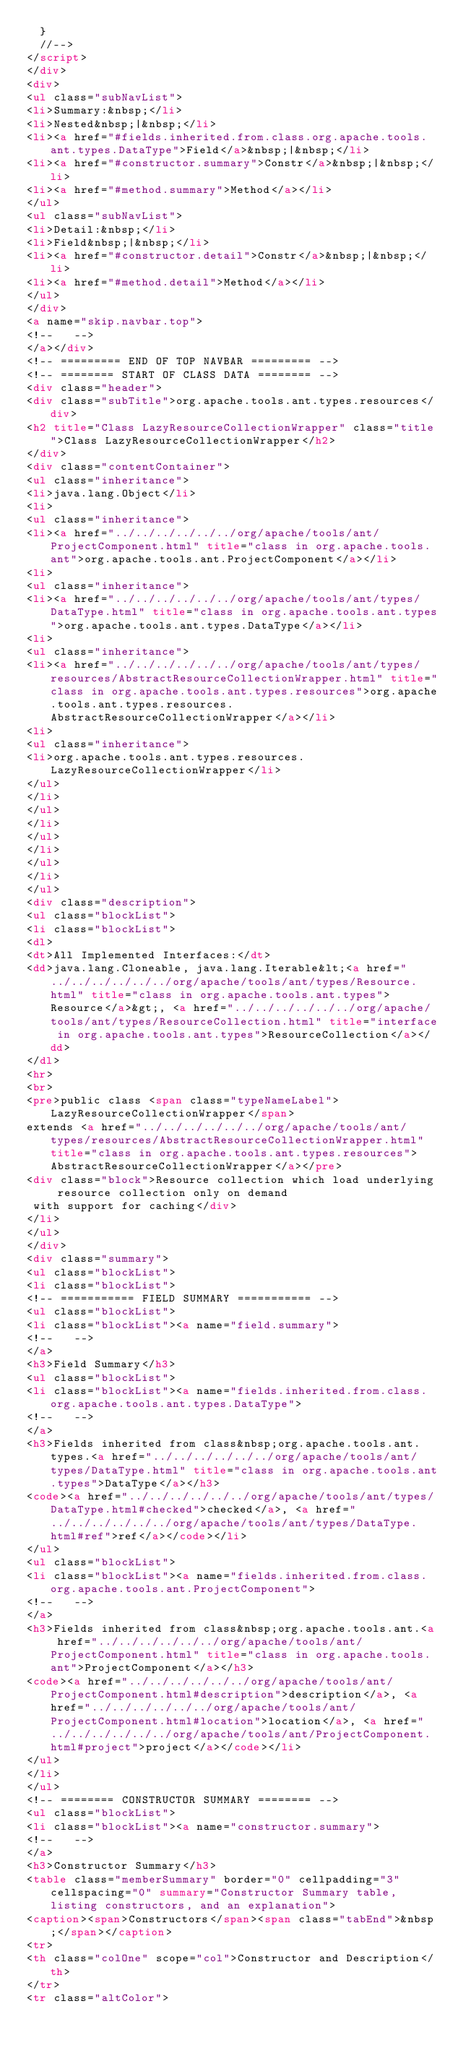Convert code to text. <code><loc_0><loc_0><loc_500><loc_500><_HTML_>  }
  //-->
</script>
</div>
<div>
<ul class="subNavList">
<li>Summary:&nbsp;</li>
<li>Nested&nbsp;|&nbsp;</li>
<li><a href="#fields.inherited.from.class.org.apache.tools.ant.types.DataType">Field</a>&nbsp;|&nbsp;</li>
<li><a href="#constructor.summary">Constr</a>&nbsp;|&nbsp;</li>
<li><a href="#method.summary">Method</a></li>
</ul>
<ul class="subNavList">
<li>Detail:&nbsp;</li>
<li>Field&nbsp;|&nbsp;</li>
<li><a href="#constructor.detail">Constr</a>&nbsp;|&nbsp;</li>
<li><a href="#method.detail">Method</a></li>
</ul>
</div>
<a name="skip.navbar.top">
<!--   -->
</a></div>
<!-- ========= END OF TOP NAVBAR ========= -->
<!-- ======== START OF CLASS DATA ======== -->
<div class="header">
<div class="subTitle">org.apache.tools.ant.types.resources</div>
<h2 title="Class LazyResourceCollectionWrapper" class="title">Class LazyResourceCollectionWrapper</h2>
</div>
<div class="contentContainer">
<ul class="inheritance">
<li>java.lang.Object</li>
<li>
<ul class="inheritance">
<li><a href="../../../../../../org/apache/tools/ant/ProjectComponent.html" title="class in org.apache.tools.ant">org.apache.tools.ant.ProjectComponent</a></li>
<li>
<ul class="inheritance">
<li><a href="../../../../../../org/apache/tools/ant/types/DataType.html" title="class in org.apache.tools.ant.types">org.apache.tools.ant.types.DataType</a></li>
<li>
<ul class="inheritance">
<li><a href="../../../../../../org/apache/tools/ant/types/resources/AbstractResourceCollectionWrapper.html" title="class in org.apache.tools.ant.types.resources">org.apache.tools.ant.types.resources.AbstractResourceCollectionWrapper</a></li>
<li>
<ul class="inheritance">
<li>org.apache.tools.ant.types.resources.LazyResourceCollectionWrapper</li>
</ul>
</li>
</ul>
</li>
</ul>
</li>
</ul>
</li>
</ul>
<div class="description">
<ul class="blockList">
<li class="blockList">
<dl>
<dt>All Implemented Interfaces:</dt>
<dd>java.lang.Cloneable, java.lang.Iterable&lt;<a href="../../../../../../org/apache/tools/ant/types/Resource.html" title="class in org.apache.tools.ant.types">Resource</a>&gt;, <a href="../../../../../../org/apache/tools/ant/types/ResourceCollection.html" title="interface in org.apache.tools.ant.types">ResourceCollection</a></dd>
</dl>
<hr>
<br>
<pre>public class <span class="typeNameLabel">LazyResourceCollectionWrapper</span>
extends <a href="../../../../../../org/apache/tools/ant/types/resources/AbstractResourceCollectionWrapper.html" title="class in org.apache.tools.ant.types.resources">AbstractResourceCollectionWrapper</a></pre>
<div class="block">Resource collection which load underlying resource collection only on demand
 with support for caching</div>
</li>
</ul>
</div>
<div class="summary">
<ul class="blockList">
<li class="blockList">
<!-- =========== FIELD SUMMARY =========== -->
<ul class="blockList">
<li class="blockList"><a name="field.summary">
<!--   -->
</a>
<h3>Field Summary</h3>
<ul class="blockList">
<li class="blockList"><a name="fields.inherited.from.class.org.apache.tools.ant.types.DataType">
<!--   -->
</a>
<h3>Fields inherited from class&nbsp;org.apache.tools.ant.types.<a href="../../../../../../org/apache/tools/ant/types/DataType.html" title="class in org.apache.tools.ant.types">DataType</a></h3>
<code><a href="../../../../../../org/apache/tools/ant/types/DataType.html#checked">checked</a>, <a href="../../../../../../org/apache/tools/ant/types/DataType.html#ref">ref</a></code></li>
</ul>
<ul class="blockList">
<li class="blockList"><a name="fields.inherited.from.class.org.apache.tools.ant.ProjectComponent">
<!--   -->
</a>
<h3>Fields inherited from class&nbsp;org.apache.tools.ant.<a href="../../../../../../org/apache/tools/ant/ProjectComponent.html" title="class in org.apache.tools.ant">ProjectComponent</a></h3>
<code><a href="../../../../../../org/apache/tools/ant/ProjectComponent.html#description">description</a>, <a href="../../../../../../org/apache/tools/ant/ProjectComponent.html#location">location</a>, <a href="../../../../../../org/apache/tools/ant/ProjectComponent.html#project">project</a></code></li>
</ul>
</li>
</ul>
<!-- ======== CONSTRUCTOR SUMMARY ======== -->
<ul class="blockList">
<li class="blockList"><a name="constructor.summary">
<!--   -->
</a>
<h3>Constructor Summary</h3>
<table class="memberSummary" border="0" cellpadding="3" cellspacing="0" summary="Constructor Summary table, listing constructors, and an explanation">
<caption><span>Constructors</span><span class="tabEnd">&nbsp;</span></caption>
<tr>
<th class="colOne" scope="col">Constructor and Description</th>
</tr>
<tr class="altColor"></code> 